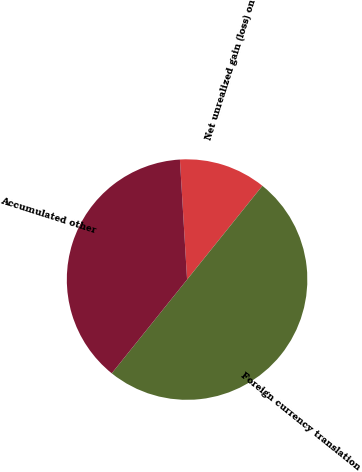<chart> <loc_0><loc_0><loc_500><loc_500><pie_chart><fcel>Net unrealized gain (loss) on<fcel>Foreign currency translation<fcel>Accumulated other<nl><fcel>11.72%<fcel>50.0%<fcel>38.28%<nl></chart> 